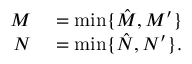<formula> <loc_0><loc_0><loc_500><loc_500>\begin{array} { r l } { M } & = \min \{ \hat { M } , M ^ { \prime } \} } \\ { N } & = \min \{ \hat { N } , N ^ { \prime } \} . } \end{array}</formula> 